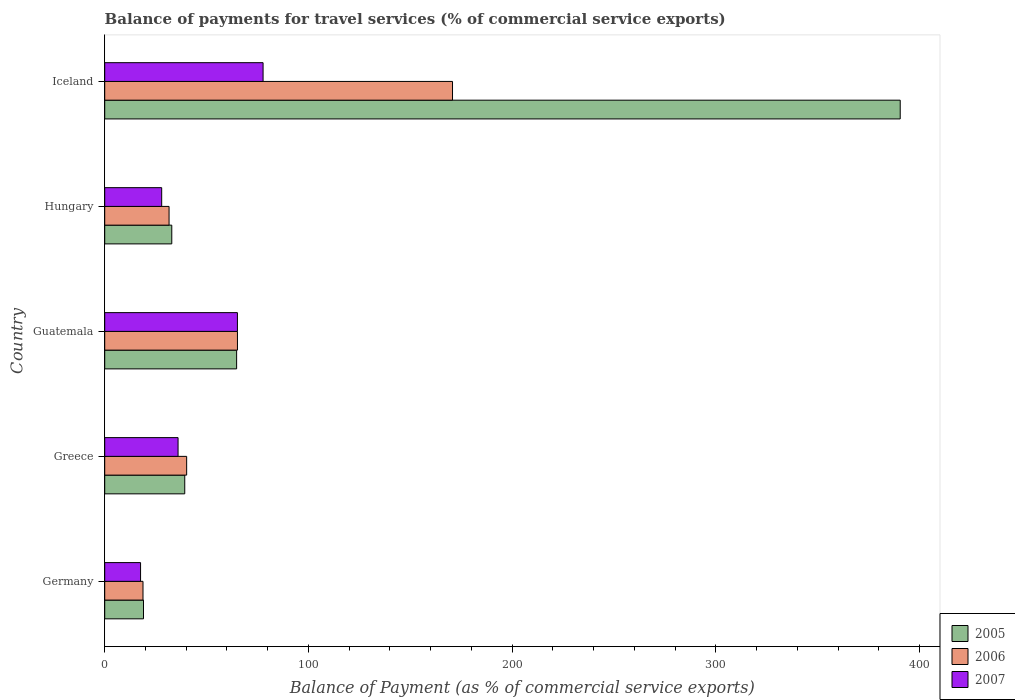Are the number of bars per tick equal to the number of legend labels?
Make the answer very short. Yes. How many bars are there on the 4th tick from the bottom?
Ensure brevity in your answer.  3. What is the label of the 4th group of bars from the top?
Keep it short and to the point. Greece. In how many cases, is the number of bars for a given country not equal to the number of legend labels?
Give a very brief answer. 0. What is the balance of payments for travel services in 2005 in Greece?
Make the answer very short. 39.28. Across all countries, what is the maximum balance of payments for travel services in 2006?
Give a very brief answer. 170.69. Across all countries, what is the minimum balance of payments for travel services in 2007?
Offer a very short reply. 17.59. What is the total balance of payments for travel services in 2006 in the graph?
Ensure brevity in your answer.  326.43. What is the difference between the balance of payments for travel services in 2007 in Hungary and that in Iceland?
Give a very brief answer. -49.76. What is the difference between the balance of payments for travel services in 2005 in Iceland and the balance of payments for travel services in 2006 in Hungary?
Keep it short and to the point. 358.84. What is the average balance of payments for travel services in 2006 per country?
Your response must be concise. 65.29. What is the difference between the balance of payments for travel services in 2007 and balance of payments for travel services in 2006 in Greece?
Make the answer very short. -4.22. In how many countries, is the balance of payments for travel services in 2005 greater than 40 %?
Make the answer very short. 2. What is the ratio of the balance of payments for travel services in 2007 in Greece to that in Guatemala?
Offer a very short reply. 0.55. Is the difference between the balance of payments for travel services in 2007 in Greece and Iceland greater than the difference between the balance of payments for travel services in 2006 in Greece and Iceland?
Offer a very short reply. Yes. What is the difference between the highest and the second highest balance of payments for travel services in 2005?
Make the answer very short. 325.68. What is the difference between the highest and the lowest balance of payments for travel services in 2007?
Make the answer very short. 60.13. What does the 3rd bar from the top in Greece represents?
Offer a very short reply. 2005. How are the legend labels stacked?
Your answer should be compact. Vertical. What is the title of the graph?
Your answer should be compact. Balance of payments for travel services (% of commercial service exports). Does "1983" appear as one of the legend labels in the graph?
Provide a succinct answer. No. What is the label or title of the X-axis?
Provide a succinct answer. Balance of Payment (as % of commercial service exports). What is the Balance of Payment (as % of commercial service exports) in 2005 in Germany?
Ensure brevity in your answer.  19.04. What is the Balance of Payment (as % of commercial service exports) of 2006 in Germany?
Offer a very short reply. 18.79. What is the Balance of Payment (as % of commercial service exports) of 2007 in Germany?
Provide a short and direct response. 17.59. What is the Balance of Payment (as % of commercial service exports) of 2005 in Greece?
Provide a short and direct response. 39.28. What is the Balance of Payment (as % of commercial service exports) of 2006 in Greece?
Make the answer very short. 40.22. What is the Balance of Payment (as % of commercial service exports) of 2007 in Greece?
Provide a succinct answer. 36. What is the Balance of Payment (as % of commercial service exports) of 2005 in Guatemala?
Give a very brief answer. 64.74. What is the Balance of Payment (as % of commercial service exports) in 2006 in Guatemala?
Ensure brevity in your answer.  65.15. What is the Balance of Payment (as % of commercial service exports) in 2007 in Guatemala?
Offer a very short reply. 65.13. What is the Balance of Payment (as % of commercial service exports) of 2005 in Hungary?
Offer a terse response. 32.91. What is the Balance of Payment (as % of commercial service exports) of 2006 in Hungary?
Ensure brevity in your answer.  31.58. What is the Balance of Payment (as % of commercial service exports) of 2007 in Hungary?
Provide a short and direct response. 27.96. What is the Balance of Payment (as % of commercial service exports) in 2005 in Iceland?
Your response must be concise. 390.42. What is the Balance of Payment (as % of commercial service exports) in 2006 in Iceland?
Your answer should be very brief. 170.69. What is the Balance of Payment (as % of commercial service exports) in 2007 in Iceland?
Ensure brevity in your answer.  77.72. Across all countries, what is the maximum Balance of Payment (as % of commercial service exports) in 2005?
Your answer should be compact. 390.42. Across all countries, what is the maximum Balance of Payment (as % of commercial service exports) in 2006?
Provide a short and direct response. 170.69. Across all countries, what is the maximum Balance of Payment (as % of commercial service exports) of 2007?
Offer a terse response. 77.72. Across all countries, what is the minimum Balance of Payment (as % of commercial service exports) of 2005?
Offer a terse response. 19.04. Across all countries, what is the minimum Balance of Payment (as % of commercial service exports) of 2006?
Provide a succinct answer. 18.79. Across all countries, what is the minimum Balance of Payment (as % of commercial service exports) of 2007?
Your answer should be compact. 17.59. What is the total Balance of Payment (as % of commercial service exports) in 2005 in the graph?
Your answer should be compact. 546.39. What is the total Balance of Payment (as % of commercial service exports) in 2006 in the graph?
Offer a very short reply. 326.43. What is the total Balance of Payment (as % of commercial service exports) of 2007 in the graph?
Make the answer very short. 224.41. What is the difference between the Balance of Payment (as % of commercial service exports) in 2005 in Germany and that in Greece?
Keep it short and to the point. -20.24. What is the difference between the Balance of Payment (as % of commercial service exports) of 2006 in Germany and that in Greece?
Offer a terse response. -21.43. What is the difference between the Balance of Payment (as % of commercial service exports) in 2007 in Germany and that in Greece?
Your response must be concise. -18.41. What is the difference between the Balance of Payment (as % of commercial service exports) of 2005 in Germany and that in Guatemala?
Your response must be concise. -45.7. What is the difference between the Balance of Payment (as % of commercial service exports) of 2006 in Germany and that in Guatemala?
Ensure brevity in your answer.  -46.36. What is the difference between the Balance of Payment (as % of commercial service exports) in 2007 in Germany and that in Guatemala?
Provide a succinct answer. -47.54. What is the difference between the Balance of Payment (as % of commercial service exports) of 2005 in Germany and that in Hungary?
Give a very brief answer. -13.88. What is the difference between the Balance of Payment (as % of commercial service exports) of 2006 in Germany and that in Hungary?
Make the answer very short. -12.79. What is the difference between the Balance of Payment (as % of commercial service exports) of 2007 in Germany and that in Hungary?
Provide a succinct answer. -10.37. What is the difference between the Balance of Payment (as % of commercial service exports) of 2005 in Germany and that in Iceland?
Provide a short and direct response. -371.38. What is the difference between the Balance of Payment (as % of commercial service exports) of 2006 in Germany and that in Iceland?
Provide a short and direct response. -151.9. What is the difference between the Balance of Payment (as % of commercial service exports) of 2007 in Germany and that in Iceland?
Your response must be concise. -60.13. What is the difference between the Balance of Payment (as % of commercial service exports) in 2005 in Greece and that in Guatemala?
Provide a succinct answer. -25.46. What is the difference between the Balance of Payment (as % of commercial service exports) in 2006 in Greece and that in Guatemala?
Provide a short and direct response. -24.93. What is the difference between the Balance of Payment (as % of commercial service exports) of 2007 in Greece and that in Guatemala?
Offer a terse response. -29.13. What is the difference between the Balance of Payment (as % of commercial service exports) of 2005 in Greece and that in Hungary?
Ensure brevity in your answer.  6.37. What is the difference between the Balance of Payment (as % of commercial service exports) in 2006 in Greece and that in Hungary?
Keep it short and to the point. 8.64. What is the difference between the Balance of Payment (as % of commercial service exports) of 2007 in Greece and that in Hungary?
Your answer should be compact. 8.04. What is the difference between the Balance of Payment (as % of commercial service exports) in 2005 in Greece and that in Iceland?
Your answer should be very brief. -351.14. What is the difference between the Balance of Payment (as % of commercial service exports) of 2006 in Greece and that in Iceland?
Make the answer very short. -130.48. What is the difference between the Balance of Payment (as % of commercial service exports) of 2007 in Greece and that in Iceland?
Provide a short and direct response. -41.72. What is the difference between the Balance of Payment (as % of commercial service exports) in 2005 in Guatemala and that in Hungary?
Provide a succinct answer. 31.82. What is the difference between the Balance of Payment (as % of commercial service exports) of 2006 in Guatemala and that in Hungary?
Give a very brief answer. 33.57. What is the difference between the Balance of Payment (as % of commercial service exports) of 2007 in Guatemala and that in Hungary?
Offer a very short reply. 37.17. What is the difference between the Balance of Payment (as % of commercial service exports) of 2005 in Guatemala and that in Iceland?
Your answer should be very brief. -325.68. What is the difference between the Balance of Payment (as % of commercial service exports) in 2006 in Guatemala and that in Iceland?
Your response must be concise. -105.55. What is the difference between the Balance of Payment (as % of commercial service exports) in 2007 in Guatemala and that in Iceland?
Offer a very short reply. -12.59. What is the difference between the Balance of Payment (as % of commercial service exports) in 2005 in Hungary and that in Iceland?
Offer a very short reply. -357.51. What is the difference between the Balance of Payment (as % of commercial service exports) in 2006 in Hungary and that in Iceland?
Ensure brevity in your answer.  -139.11. What is the difference between the Balance of Payment (as % of commercial service exports) in 2007 in Hungary and that in Iceland?
Your answer should be very brief. -49.76. What is the difference between the Balance of Payment (as % of commercial service exports) of 2005 in Germany and the Balance of Payment (as % of commercial service exports) of 2006 in Greece?
Your response must be concise. -21.18. What is the difference between the Balance of Payment (as % of commercial service exports) of 2005 in Germany and the Balance of Payment (as % of commercial service exports) of 2007 in Greece?
Make the answer very short. -16.96. What is the difference between the Balance of Payment (as % of commercial service exports) in 2006 in Germany and the Balance of Payment (as % of commercial service exports) in 2007 in Greece?
Your answer should be very brief. -17.21. What is the difference between the Balance of Payment (as % of commercial service exports) of 2005 in Germany and the Balance of Payment (as % of commercial service exports) of 2006 in Guatemala?
Give a very brief answer. -46.11. What is the difference between the Balance of Payment (as % of commercial service exports) of 2005 in Germany and the Balance of Payment (as % of commercial service exports) of 2007 in Guatemala?
Offer a very short reply. -46.1. What is the difference between the Balance of Payment (as % of commercial service exports) of 2006 in Germany and the Balance of Payment (as % of commercial service exports) of 2007 in Guatemala?
Make the answer very short. -46.34. What is the difference between the Balance of Payment (as % of commercial service exports) in 2005 in Germany and the Balance of Payment (as % of commercial service exports) in 2006 in Hungary?
Make the answer very short. -12.54. What is the difference between the Balance of Payment (as % of commercial service exports) in 2005 in Germany and the Balance of Payment (as % of commercial service exports) in 2007 in Hungary?
Offer a terse response. -8.93. What is the difference between the Balance of Payment (as % of commercial service exports) in 2006 in Germany and the Balance of Payment (as % of commercial service exports) in 2007 in Hungary?
Make the answer very short. -9.17. What is the difference between the Balance of Payment (as % of commercial service exports) of 2005 in Germany and the Balance of Payment (as % of commercial service exports) of 2006 in Iceland?
Your answer should be compact. -151.66. What is the difference between the Balance of Payment (as % of commercial service exports) of 2005 in Germany and the Balance of Payment (as % of commercial service exports) of 2007 in Iceland?
Your answer should be compact. -58.68. What is the difference between the Balance of Payment (as % of commercial service exports) in 2006 in Germany and the Balance of Payment (as % of commercial service exports) in 2007 in Iceland?
Ensure brevity in your answer.  -58.93. What is the difference between the Balance of Payment (as % of commercial service exports) of 2005 in Greece and the Balance of Payment (as % of commercial service exports) of 2006 in Guatemala?
Make the answer very short. -25.87. What is the difference between the Balance of Payment (as % of commercial service exports) of 2005 in Greece and the Balance of Payment (as % of commercial service exports) of 2007 in Guatemala?
Ensure brevity in your answer.  -25.85. What is the difference between the Balance of Payment (as % of commercial service exports) of 2006 in Greece and the Balance of Payment (as % of commercial service exports) of 2007 in Guatemala?
Your answer should be compact. -24.92. What is the difference between the Balance of Payment (as % of commercial service exports) in 2005 in Greece and the Balance of Payment (as % of commercial service exports) in 2007 in Hungary?
Offer a terse response. 11.32. What is the difference between the Balance of Payment (as % of commercial service exports) of 2006 in Greece and the Balance of Payment (as % of commercial service exports) of 2007 in Hungary?
Provide a short and direct response. 12.25. What is the difference between the Balance of Payment (as % of commercial service exports) of 2005 in Greece and the Balance of Payment (as % of commercial service exports) of 2006 in Iceland?
Offer a very short reply. -131.41. What is the difference between the Balance of Payment (as % of commercial service exports) of 2005 in Greece and the Balance of Payment (as % of commercial service exports) of 2007 in Iceland?
Make the answer very short. -38.44. What is the difference between the Balance of Payment (as % of commercial service exports) in 2006 in Greece and the Balance of Payment (as % of commercial service exports) in 2007 in Iceland?
Provide a succinct answer. -37.5. What is the difference between the Balance of Payment (as % of commercial service exports) in 2005 in Guatemala and the Balance of Payment (as % of commercial service exports) in 2006 in Hungary?
Your answer should be compact. 33.16. What is the difference between the Balance of Payment (as % of commercial service exports) in 2005 in Guatemala and the Balance of Payment (as % of commercial service exports) in 2007 in Hungary?
Provide a short and direct response. 36.77. What is the difference between the Balance of Payment (as % of commercial service exports) in 2006 in Guatemala and the Balance of Payment (as % of commercial service exports) in 2007 in Hungary?
Offer a terse response. 37.18. What is the difference between the Balance of Payment (as % of commercial service exports) of 2005 in Guatemala and the Balance of Payment (as % of commercial service exports) of 2006 in Iceland?
Your answer should be very brief. -105.96. What is the difference between the Balance of Payment (as % of commercial service exports) of 2005 in Guatemala and the Balance of Payment (as % of commercial service exports) of 2007 in Iceland?
Keep it short and to the point. -12.98. What is the difference between the Balance of Payment (as % of commercial service exports) in 2006 in Guatemala and the Balance of Payment (as % of commercial service exports) in 2007 in Iceland?
Your answer should be compact. -12.57. What is the difference between the Balance of Payment (as % of commercial service exports) of 2005 in Hungary and the Balance of Payment (as % of commercial service exports) of 2006 in Iceland?
Keep it short and to the point. -137.78. What is the difference between the Balance of Payment (as % of commercial service exports) in 2005 in Hungary and the Balance of Payment (as % of commercial service exports) in 2007 in Iceland?
Your answer should be very brief. -44.81. What is the difference between the Balance of Payment (as % of commercial service exports) of 2006 in Hungary and the Balance of Payment (as % of commercial service exports) of 2007 in Iceland?
Keep it short and to the point. -46.14. What is the average Balance of Payment (as % of commercial service exports) in 2005 per country?
Ensure brevity in your answer.  109.28. What is the average Balance of Payment (as % of commercial service exports) in 2006 per country?
Your answer should be compact. 65.29. What is the average Balance of Payment (as % of commercial service exports) of 2007 per country?
Offer a terse response. 44.88. What is the difference between the Balance of Payment (as % of commercial service exports) in 2005 and Balance of Payment (as % of commercial service exports) in 2006 in Germany?
Make the answer very short. 0.25. What is the difference between the Balance of Payment (as % of commercial service exports) in 2005 and Balance of Payment (as % of commercial service exports) in 2007 in Germany?
Provide a short and direct response. 1.44. What is the difference between the Balance of Payment (as % of commercial service exports) in 2006 and Balance of Payment (as % of commercial service exports) in 2007 in Germany?
Provide a succinct answer. 1.2. What is the difference between the Balance of Payment (as % of commercial service exports) in 2005 and Balance of Payment (as % of commercial service exports) in 2006 in Greece?
Offer a very short reply. -0.94. What is the difference between the Balance of Payment (as % of commercial service exports) of 2005 and Balance of Payment (as % of commercial service exports) of 2007 in Greece?
Provide a succinct answer. 3.28. What is the difference between the Balance of Payment (as % of commercial service exports) in 2006 and Balance of Payment (as % of commercial service exports) in 2007 in Greece?
Provide a short and direct response. 4.22. What is the difference between the Balance of Payment (as % of commercial service exports) of 2005 and Balance of Payment (as % of commercial service exports) of 2006 in Guatemala?
Offer a very short reply. -0.41. What is the difference between the Balance of Payment (as % of commercial service exports) in 2005 and Balance of Payment (as % of commercial service exports) in 2007 in Guatemala?
Give a very brief answer. -0.4. What is the difference between the Balance of Payment (as % of commercial service exports) of 2006 and Balance of Payment (as % of commercial service exports) of 2007 in Guatemala?
Give a very brief answer. 0.01. What is the difference between the Balance of Payment (as % of commercial service exports) of 2005 and Balance of Payment (as % of commercial service exports) of 2006 in Hungary?
Give a very brief answer. 1.33. What is the difference between the Balance of Payment (as % of commercial service exports) in 2005 and Balance of Payment (as % of commercial service exports) in 2007 in Hungary?
Your answer should be very brief. 4.95. What is the difference between the Balance of Payment (as % of commercial service exports) in 2006 and Balance of Payment (as % of commercial service exports) in 2007 in Hungary?
Your response must be concise. 3.62. What is the difference between the Balance of Payment (as % of commercial service exports) of 2005 and Balance of Payment (as % of commercial service exports) of 2006 in Iceland?
Offer a terse response. 219.73. What is the difference between the Balance of Payment (as % of commercial service exports) in 2005 and Balance of Payment (as % of commercial service exports) in 2007 in Iceland?
Offer a terse response. 312.7. What is the difference between the Balance of Payment (as % of commercial service exports) of 2006 and Balance of Payment (as % of commercial service exports) of 2007 in Iceland?
Give a very brief answer. 92.98. What is the ratio of the Balance of Payment (as % of commercial service exports) of 2005 in Germany to that in Greece?
Your response must be concise. 0.48. What is the ratio of the Balance of Payment (as % of commercial service exports) of 2006 in Germany to that in Greece?
Provide a succinct answer. 0.47. What is the ratio of the Balance of Payment (as % of commercial service exports) of 2007 in Germany to that in Greece?
Your answer should be compact. 0.49. What is the ratio of the Balance of Payment (as % of commercial service exports) in 2005 in Germany to that in Guatemala?
Make the answer very short. 0.29. What is the ratio of the Balance of Payment (as % of commercial service exports) of 2006 in Germany to that in Guatemala?
Provide a succinct answer. 0.29. What is the ratio of the Balance of Payment (as % of commercial service exports) in 2007 in Germany to that in Guatemala?
Provide a succinct answer. 0.27. What is the ratio of the Balance of Payment (as % of commercial service exports) in 2005 in Germany to that in Hungary?
Offer a terse response. 0.58. What is the ratio of the Balance of Payment (as % of commercial service exports) of 2006 in Germany to that in Hungary?
Your answer should be compact. 0.59. What is the ratio of the Balance of Payment (as % of commercial service exports) in 2007 in Germany to that in Hungary?
Ensure brevity in your answer.  0.63. What is the ratio of the Balance of Payment (as % of commercial service exports) of 2005 in Germany to that in Iceland?
Give a very brief answer. 0.05. What is the ratio of the Balance of Payment (as % of commercial service exports) of 2006 in Germany to that in Iceland?
Provide a short and direct response. 0.11. What is the ratio of the Balance of Payment (as % of commercial service exports) of 2007 in Germany to that in Iceland?
Provide a short and direct response. 0.23. What is the ratio of the Balance of Payment (as % of commercial service exports) in 2005 in Greece to that in Guatemala?
Offer a very short reply. 0.61. What is the ratio of the Balance of Payment (as % of commercial service exports) of 2006 in Greece to that in Guatemala?
Offer a terse response. 0.62. What is the ratio of the Balance of Payment (as % of commercial service exports) of 2007 in Greece to that in Guatemala?
Make the answer very short. 0.55. What is the ratio of the Balance of Payment (as % of commercial service exports) of 2005 in Greece to that in Hungary?
Provide a short and direct response. 1.19. What is the ratio of the Balance of Payment (as % of commercial service exports) of 2006 in Greece to that in Hungary?
Your response must be concise. 1.27. What is the ratio of the Balance of Payment (as % of commercial service exports) in 2007 in Greece to that in Hungary?
Provide a succinct answer. 1.29. What is the ratio of the Balance of Payment (as % of commercial service exports) of 2005 in Greece to that in Iceland?
Provide a succinct answer. 0.1. What is the ratio of the Balance of Payment (as % of commercial service exports) in 2006 in Greece to that in Iceland?
Offer a terse response. 0.24. What is the ratio of the Balance of Payment (as % of commercial service exports) of 2007 in Greece to that in Iceland?
Give a very brief answer. 0.46. What is the ratio of the Balance of Payment (as % of commercial service exports) in 2005 in Guatemala to that in Hungary?
Your answer should be very brief. 1.97. What is the ratio of the Balance of Payment (as % of commercial service exports) in 2006 in Guatemala to that in Hungary?
Ensure brevity in your answer.  2.06. What is the ratio of the Balance of Payment (as % of commercial service exports) in 2007 in Guatemala to that in Hungary?
Make the answer very short. 2.33. What is the ratio of the Balance of Payment (as % of commercial service exports) in 2005 in Guatemala to that in Iceland?
Your answer should be compact. 0.17. What is the ratio of the Balance of Payment (as % of commercial service exports) in 2006 in Guatemala to that in Iceland?
Give a very brief answer. 0.38. What is the ratio of the Balance of Payment (as % of commercial service exports) of 2007 in Guatemala to that in Iceland?
Keep it short and to the point. 0.84. What is the ratio of the Balance of Payment (as % of commercial service exports) of 2005 in Hungary to that in Iceland?
Give a very brief answer. 0.08. What is the ratio of the Balance of Payment (as % of commercial service exports) of 2006 in Hungary to that in Iceland?
Keep it short and to the point. 0.18. What is the ratio of the Balance of Payment (as % of commercial service exports) of 2007 in Hungary to that in Iceland?
Provide a short and direct response. 0.36. What is the difference between the highest and the second highest Balance of Payment (as % of commercial service exports) of 2005?
Give a very brief answer. 325.68. What is the difference between the highest and the second highest Balance of Payment (as % of commercial service exports) in 2006?
Provide a succinct answer. 105.55. What is the difference between the highest and the second highest Balance of Payment (as % of commercial service exports) in 2007?
Make the answer very short. 12.59. What is the difference between the highest and the lowest Balance of Payment (as % of commercial service exports) in 2005?
Make the answer very short. 371.38. What is the difference between the highest and the lowest Balance of Payment (as % of commercial service exports) of 2006?
Offer a terse response. 151.9. What is the difference between the highest and the lowest Balance of Payment (as % of commercial service exports) in 2007?
Ensure brevity in your answer.  60.13. 